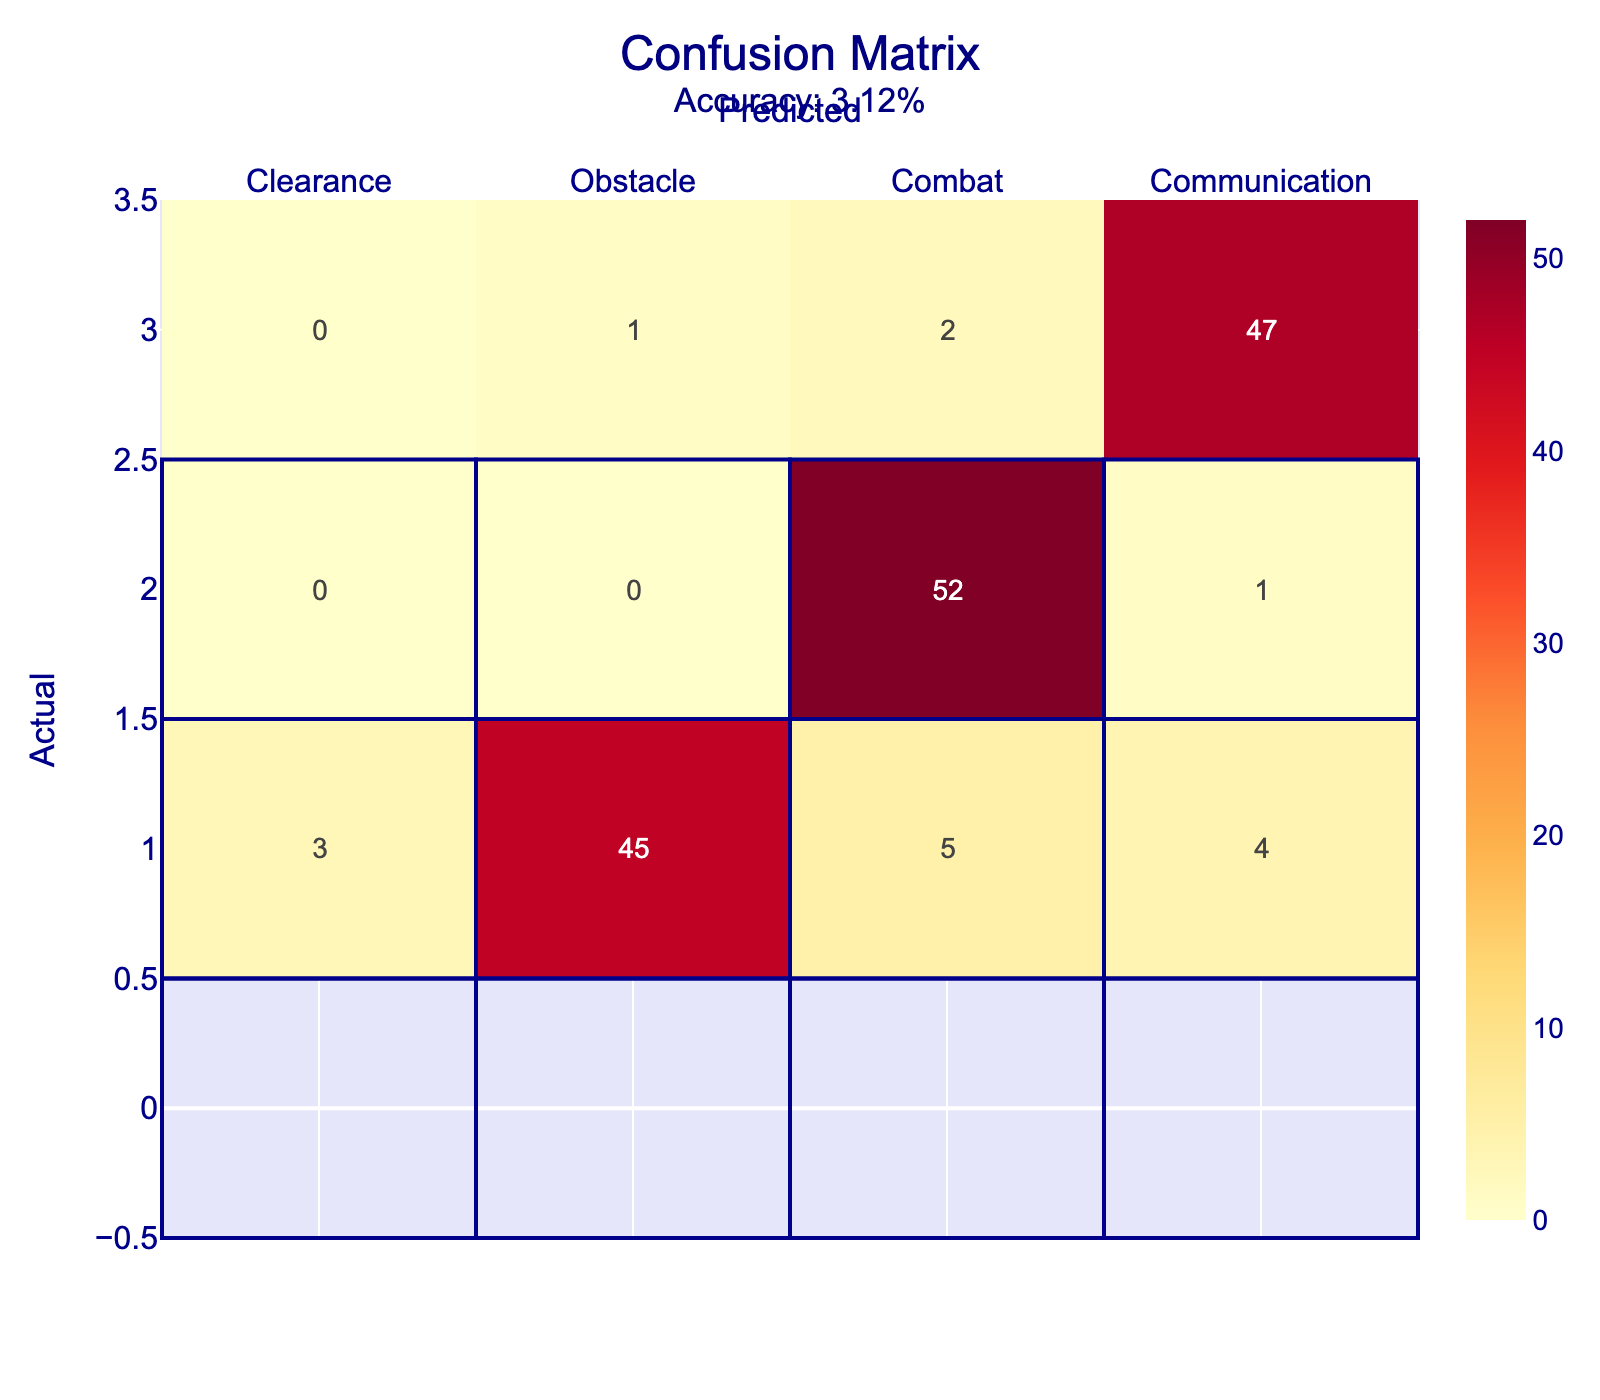What is the number of Privates who correctly identified the Clearance scenario? According to the table, the number of Privates who correctly predicted the Clearance scenario is found in the cell where Actual and Predicted both are Clearance, which has a value of 50.
Answer: 50 What is the total number of Privates who misidentified the Combat scenario? To find this, we add the values in the Combat row, excluding the correct prediction (52): 0 (Clearance) + 0 (Obstacle) + 1 (Communication) = 1. Thus, the total number of misidentifications is 1.
Answer: 1 How many Privates predicted the Obstacle scenario incorrectly? The incorrect predictions for the Obstacle scenario are found in the Obstacle row (Clearance = 3, Combat = 5, Communication = 4). Adding these gives us 3 + 5 + 4 = 12 incorrect predictions.
Answer: 12 Is it true that more Privates identified the Communication scenario than the Obstacle scenario? For the Communication scenario, the number of correct predictions is 47. For the Obstacle scenario, the number of correct predictions is 45. Since 47 is greater than 45, the statement is true.
Answer: Yes What is the overall accuracy of the Privates in this evaluation? The accuracy can be calculated by taking the trace of the confusion matrix (sum of diagonal elements: 50 + 45 + 52 + 47 = 194) and dividing it by the total number of observations (sum of all elements: 50 + 2 + 1 + 0 + 3 + 45 + 5 + 4 + 0 + 0 + 52 + 1 + 0 + 1 + 2 + 47 = 220). Thus, accuracy = 194/220 ≈ 0.88, or 88%.
Answer: 88% How many more Privates were correct in identifying the Clearance scenario compared to the Communication scenario? The number of correct identifications for Clearance is 50, and for Communication it is 47. Calculating the difference gives us 50 - 47 = 3. Therefore, 3 more Privates identified the Clearance scenario correctly.
Answer: 3 